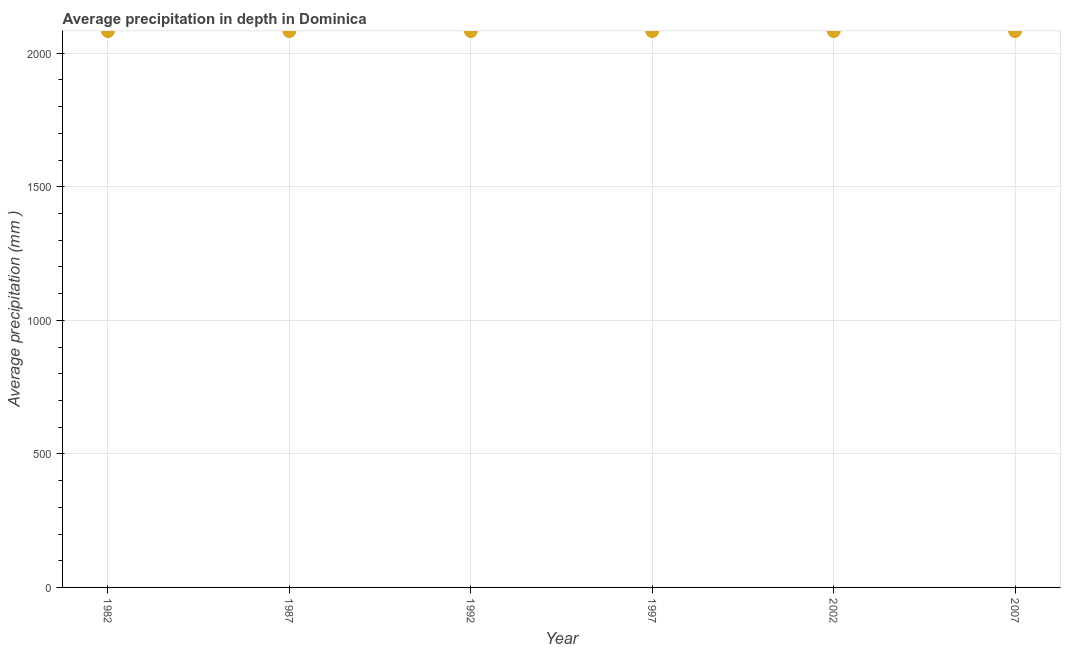What is the average precipitation in depth in 1992?
Provide a short and direct response. 2083. Across all years, what is the maximum average precipitation in depth?
Offer a terse response. 2083. Across all years, what is the minimum average precipitation in depth?
Your answer should be compact. 2083. In which year was the average precipitation in depth maximum?
Offer a very short reply. 1982. In which year was the average precipitation in depth minimum?
Ensure brevity in your answer.  1982. What is the sum of the average precipitation in depth?
Your answer should be very brief. 1.25e+04. What is the difference between the average precipitation in depth in 1982 and 1987?
Offer a very short reply. 0. What is the average average precipitation in depth per year?
Provide a succinct answer. 2083. What is the median average precipitation in depth?
Make the answer very short. 2083. In how many years, is the average precipitation in depth greater than 600 mm?
Provide a short and direct response. 6. Do a majority of the years between 1997 and 1992 (inclusive) have average precipitation in depth greater than 800 mm?
Make the answer very short. No. Is the average precipitation in depth in 1997 less than that in 2007?
Offer a terse response. No. Is the sum of the average precipitation in depth in 1987 and 1997 greater than the maximum average precipitation in depth across all years?
Keep it short and to the point. Yes. Does the average precipitation in depth monotonically increase over the years?
Your answer should be compact. No. How many dotlines are there?
Your answer should be compact. 1. What is the difference between two consecutive major ticks on the Y-axis?
Ensure brevity in your answer.  500. Does the graph contain any zero values?
Your response must be concise. No. Does the graph contain grids?
Give a very brief answer. Yes. What is the title of the graph?
Give a very brief answer. Average precipitation in depth in Dominica. What is the label or title of the X-axis?
Your response must be concise. Year. What is the label or title of the Y-axis?
Provide a succinct answer. Average precipitation (mm ). What is the Average precipitation (mm ) in 1982?
Your answer should be compact. 2083. What is the Average precipitation (mm ) in 1987?
Ensure brevity in your answer.  2083. What is the Average precipitation (mm ) in 1992?
Give a very brief answer. 2083. What is the Average precipitation (mm ) in 1997?
Make the answer very short. 2083. What is the Average precipitation (mm ) in 2002?
Your answer should be very brief. 2083. What is the Average precipitation (mm ) in 2007?
Offer a terse response. 2083. What is the difference between the Average precipitation (mm ) in 1982 and 1987?
Provide a short and direct response. 0. What is the difference between the Average precipitation (mm ) in 1982 and 2002?
Provide a succinct answer. 0. What is the difference between the Average precipitation (mm ) in 1987 and 1992?
Your response must be concise. 0. What is the difference between the Average precipitation (mm ) in 1987 and 1997?
Keep it short and to the point. 0. What is the difference between the Average precipitation (mm ) in 1987 and 2002?
Make the answer very short. 0. What is the difference between the Average precipitation (mm ) in 1987 and 2007?
Offer a very short reply. 0. What is the difference between the Average precipitation (mm ) in 1992 and 2002?
Offer a very short reply. 0. What is the difference between the Average precipitation (mm ) in 1992 and 2007?
Make the answer very short. 0. What is the difference between the Average precipitation (mm ) in 1997 and 2002?
Your answer should be compact. 0. What is the difference between the Average precipitation (mm ) in 1997 and 2007?
Provide a succinct answer. 0. What is the difference between the Average precipitation (mm ) in 2002 and 2007?
Ensure brevity in your answer.  0. What is the ratio of the Average precipitation (mm ) in 1982 to that in 1987?
Make the answer very short. 1. What is the ratio of the Average precipitation (mm ) in 1982 to that in 1997?
Provide a succinct answer. 1. What is the ratio of the Average precipitation (mm ) in 1982 to that in 2002?
Offer a terse response. 1. What is the ratio of the Average precipitation (mm ) in 1987 to that in 2007?
Offer a very short reply. 1. What is the ratio of the Average precipitation (mm ) in 1997 to that in 2002?
Keep it short and to the point. 1. 